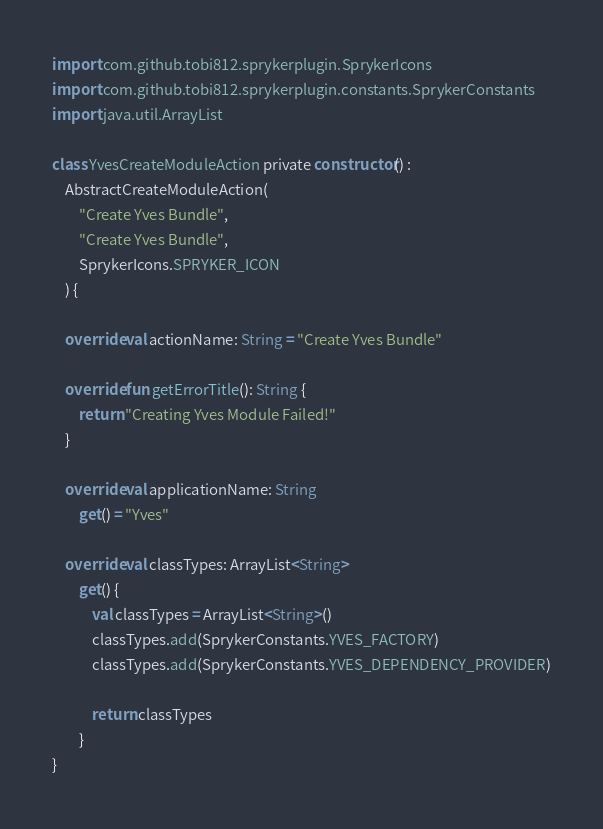<code> <loc_0><loc_0><loc_500><loc_500><_Kotlin_>
import com.github.tobi812.sprykerplugin.SprykerIcons
import com.github.tobi812.sprykerplugin.constants.SprykerConstants
import java.util.ArrayList

class YvesCreateModuleAction private constructor() :
    AbstractCreateModuleAction(
        "Create Yves Bundle",
        "Create Yves Bundle",
        SprykerIcons.SPRYKER_ICON
    ) {

    override val actionName: String = "Create Yves Bundle"

    override fun getErrorTitle(): String {
        return "Creating Yves Module Failed!"
    }

    override val applicationName: String
        get() = "Yves"

    override val classTypes: ArrayList<String>
        get() {
            val classTypes = ArrayList<String>()
            classTypes.add(SprykerConstants.YVES_FACTORY)
            classTypes.add(SprykerConstants.YVES_DEPENDENCY_PROVIDER)

            return classTypes
        }
}
</code> 